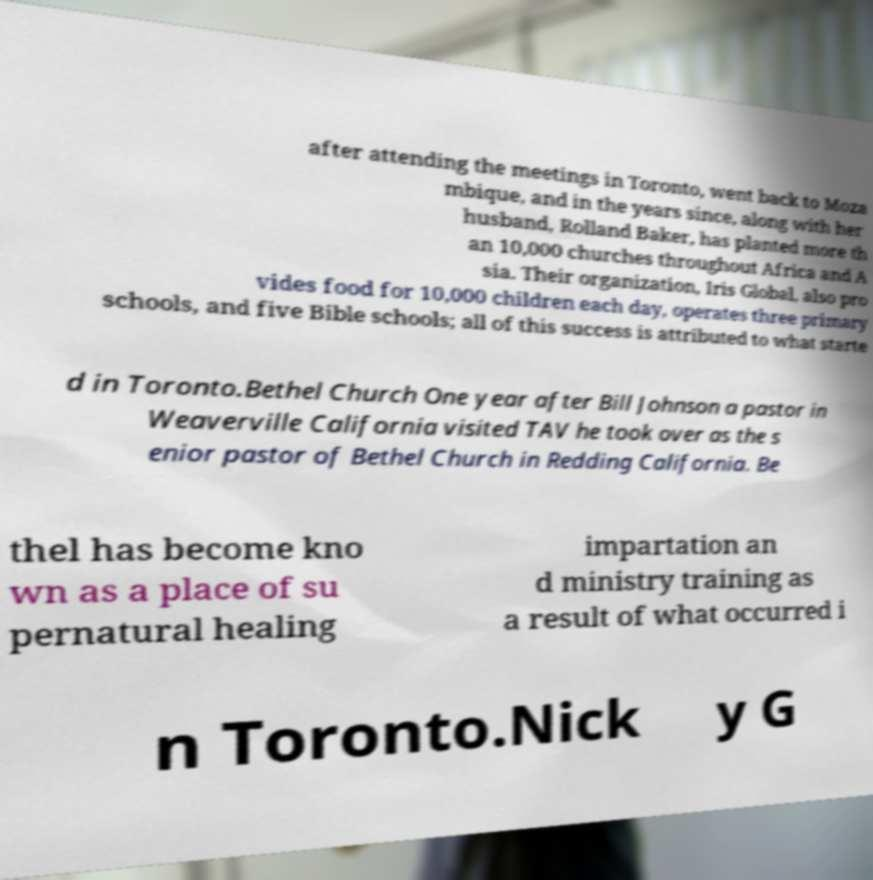For documentation purposes, I need the text within this image transcribed. Could you provide that? after attending the meetings in Toronto, went back to Moza mbique, and in the years since, along with her husband, Rolland Baker, has planted more th an 10,000 churches throughout Africa and A sia. Their organization, Iris Global, also pro vides food for 10,000 children each day, operates three primary schools, and five Bible schools; all of this success is attributed to what starte d in Toronto.Bethel Church One year after Bill Johnson a pastor in Weaverville California visited TAV he took over as the s enior pastor of Bethel Church in Redding California. Be thel has become kno wn as a place of su pernatural healing impartation an d ministry training as a result of what occurred i n Toronto.Nick y G 